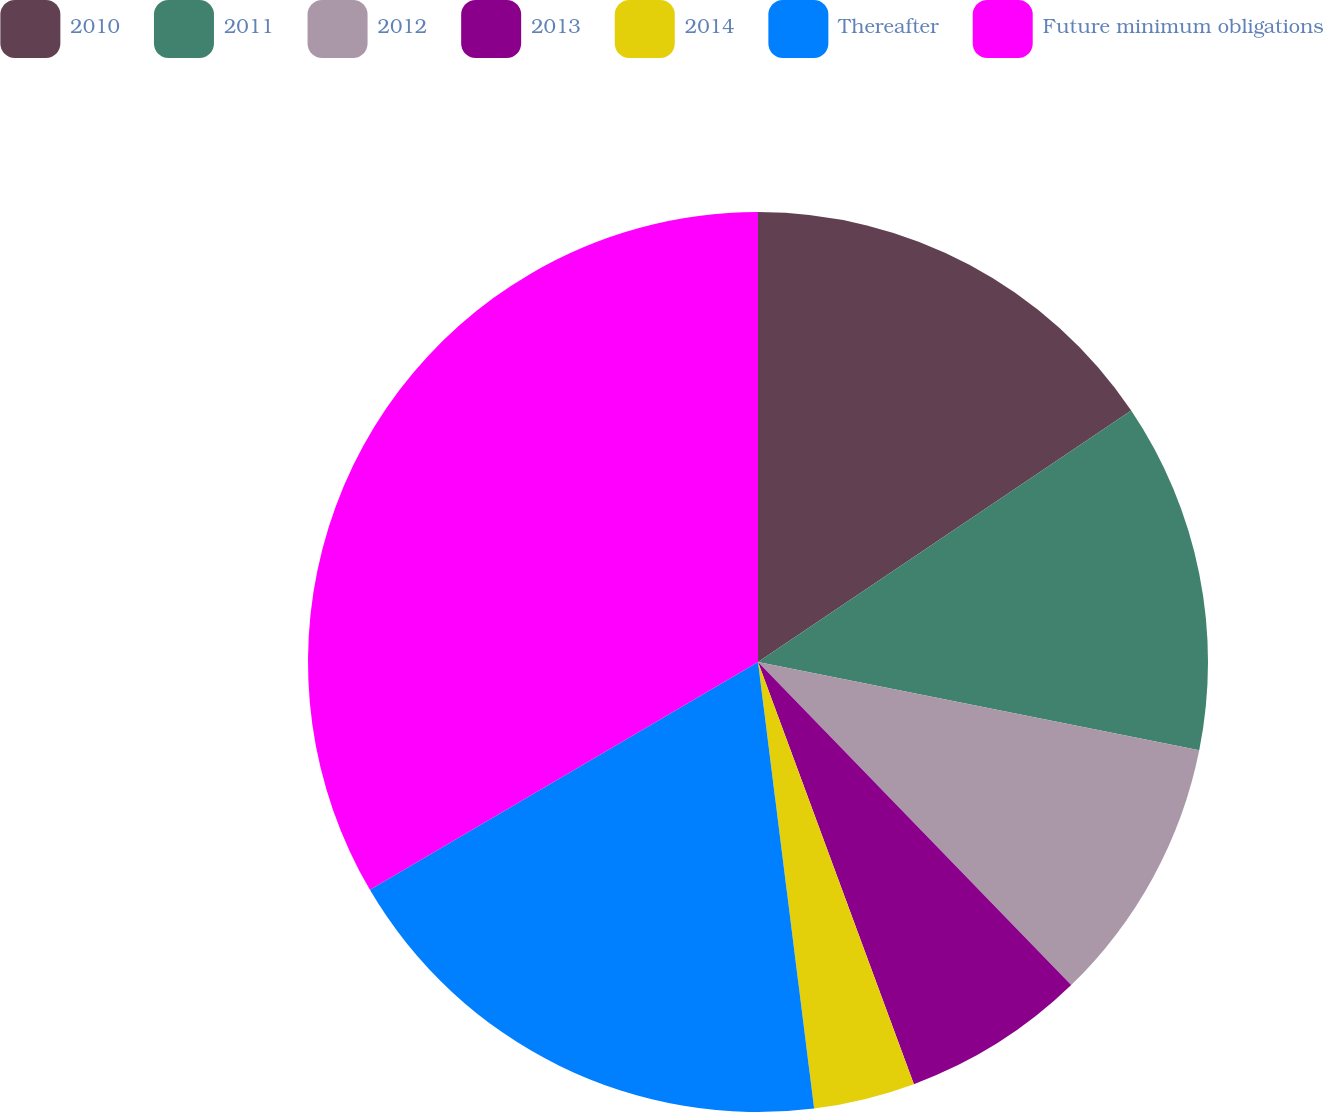Convert chart. <chart><loc_0><loc_0><loc_500><loc_500><pie_chart><fcel>2010<fcel>2011<fcel>2012<fcel>2013<fcel>2014<fcel>Thereafter<fcel>Future minimum obligations<nl><fcel>15.56%<fcel>12.58%<fcel>9.6%<fcel>6.62%<fcel>3.64%<fcel>18.54%<fcel>33.44%<nl></chart> 